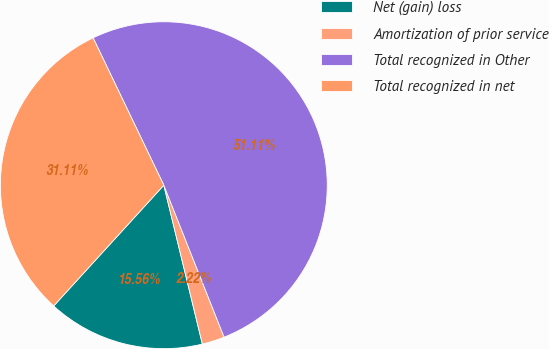<chart> <loc_0><loc_0><loc_500><loc_500><pie_chart><fcel>Net (gain) loss<fcel>Amortization of prior service<fcel>Total recognized in Other<fcel>Total recognized in net<nl><fcel>15.56%<fcel>2.22%<fcel>51.11%<fcel>31.11%<nl></chart> 